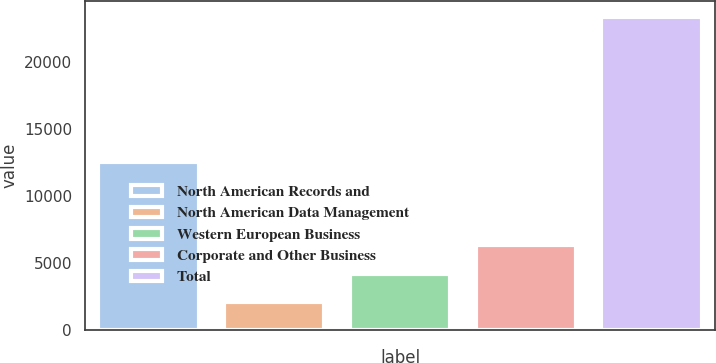Convert chart. <chart><loc_0><loc_0><loc_500><loc_500><bar_chart><fcel>North American Records and<fcel>North American Data Management<fcel>Western European Business<fcel>Corporate and Other Business<fcel>Total<nl><fcel>12600<fcel>2100<fcel>4230<fcel>6360<fcel>23400<nl></chart> 